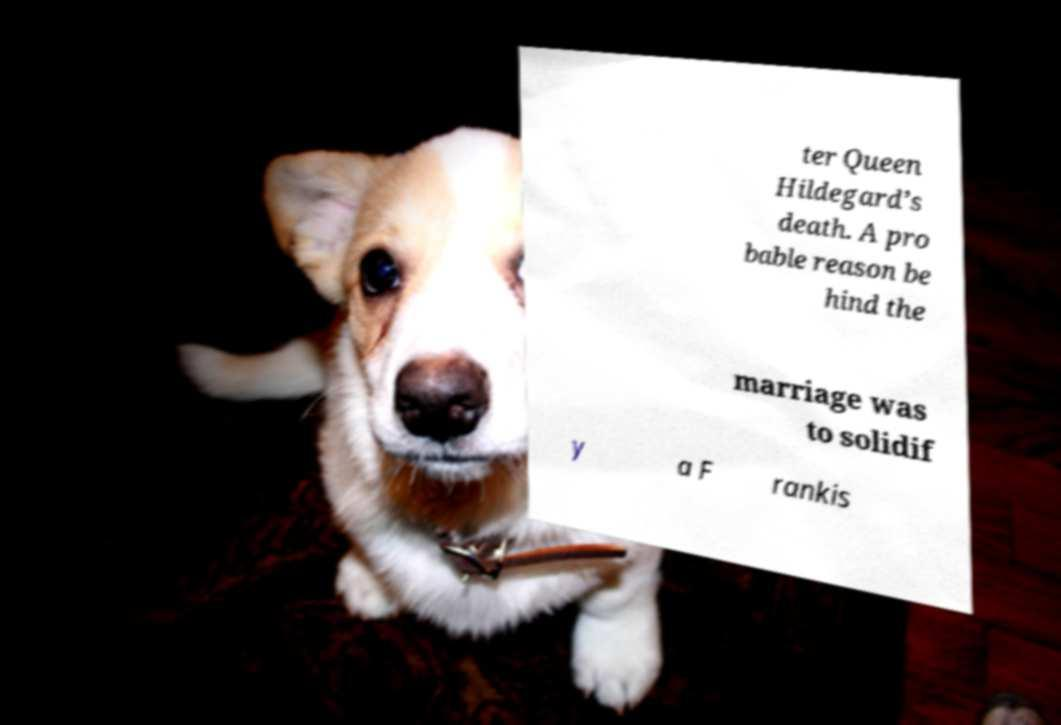What messages or text are displayed in this image? I need them in a readable, typed format. ter Queen Hildegard’s death. A pro bable reason be hind the marriage was to solidif y a F rankis 